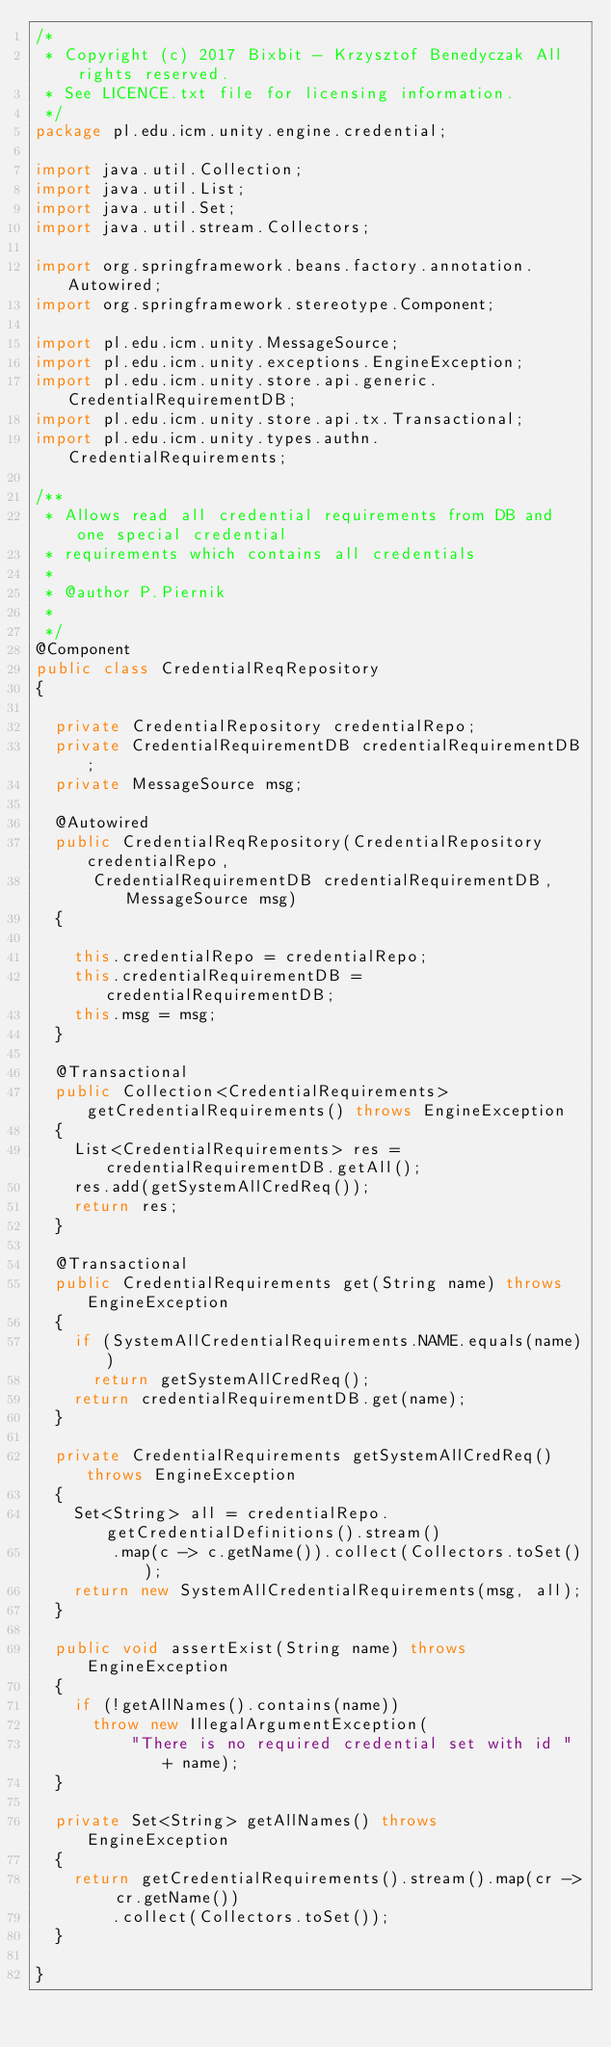Convert code to text. <code><loc_0><loc_0><loc_500><loc_500><_Java_>/*
 * Copyright (c) 2017 Bixbit - Krzysztof Benedyczak All rights reserved.
 * See LICENCE.txt file for licensing information.
 */
package pl.edu.icm.unity.engine.credential;

import java.util.Collection;
import java.util.List;
import java.util.Set;
import java.util.stream.Collectors;

import org.springframework.beans.factory.annotation.Autowired;
import org.springframework.stereotype.Component;

import pl.edu.icm.unity.MessageSource;
import pl.edu.icm.unity.exceptions.EngineException;
import pl.edu.icm.unity.store.api.generic.CredentialRequirementDB;
import pl.edu.icm.unity.store.api.tx.Transactional;
import pl.edu.icm.unity.types.authn.CredentialRequirements;

/**
 * Allows read all credential requirements from DB and one special credential
 * requirements which contains all credentials
 * 
 * @author P.Piernik
 *
 */
@Component
public class CredentialReqRepository
{

	private CredentialRepository credentialRepo;
	private CredentialRequirementDB credentialRequirementDB;
	private MessageSource msg;

	@Autowired
	public CredentialReqRepository(CredentialRepository credentialRepo,
			CredentialRequirementDB credentialRequirementDB, MessageSource msg)
	{

		this.credentialRepo = credentialRepo;
		this.credentialRequirementDB = credentialRequirementDB;
		this.msg = msg;
	}

	@Transactional
	public Collection<CredentialRequirements> getCredentialRequirements() throws EngineException
	{
		List<CredentialRequirements> res = credentialRequirementDB.getAll();
		res.add(getSystemAllCredReq());
		return res;
	}

	@Transactional
	public CredentialRequirements get(String name) throws EngineException
	{
		if (SystemAllCredentialRequirements.NAME.equals(name))
			return getSystemAllCredReq();
		return credentialRequirementDB.get(name);
	}

	private CredentialRequirements getSystemAllCredReq() throws EngineException
	{
		Set<String> all = credentialRepo.getCredentialDefinitions().stream()
				.map(c -> c.getName()).collect(Collectors.toSet());
		return new SystemAllCredentialRequirements(msg, all);
	}
	
	public void assertExist(String name) throws EngineException
	{
		if (!getAllNames().contains(name))
			throw new IllegalArgumentException(
					"There is no required credential set with id " + name);
	}

	private Set<String> getAllNames() throws EngineException
	{
		return getCredentialRequirements().stream().map(cr -> cr.getName())
				.collect(Collectors.toSet());
	}

}
</code> 